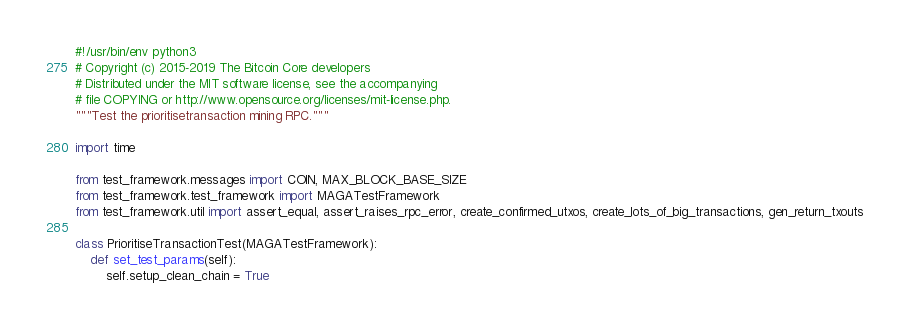Convert code to text. <code><loc_0><loc_0><loc_500><loc_500><_Python_>#!/usr/bin/env python3
# Copyright (c) 2015-2019 The Bitcoin Core developers
# Distributed under the MIT software license, see the accompanying
# file COPYING or http://www.opensource.org/licenses/mit-license.php.
"""Test the prioritisetransaction mining RPC."""

import time

from test_framework.messages import COIN, MAX_BLOCK_BASE_SIZE
from test_framework.test_framework import MAGATestFramework
from test_framework.util import assert_equal, assert_raises_rpc_error, create_confirmed_utxos, create_lots_of_big_transactions, gen_return_txouts

class PrioritiseTransactionTest(MAGATestFramework):
    def set_test_params(self):
        self.setup_clean_chain = True</code> 